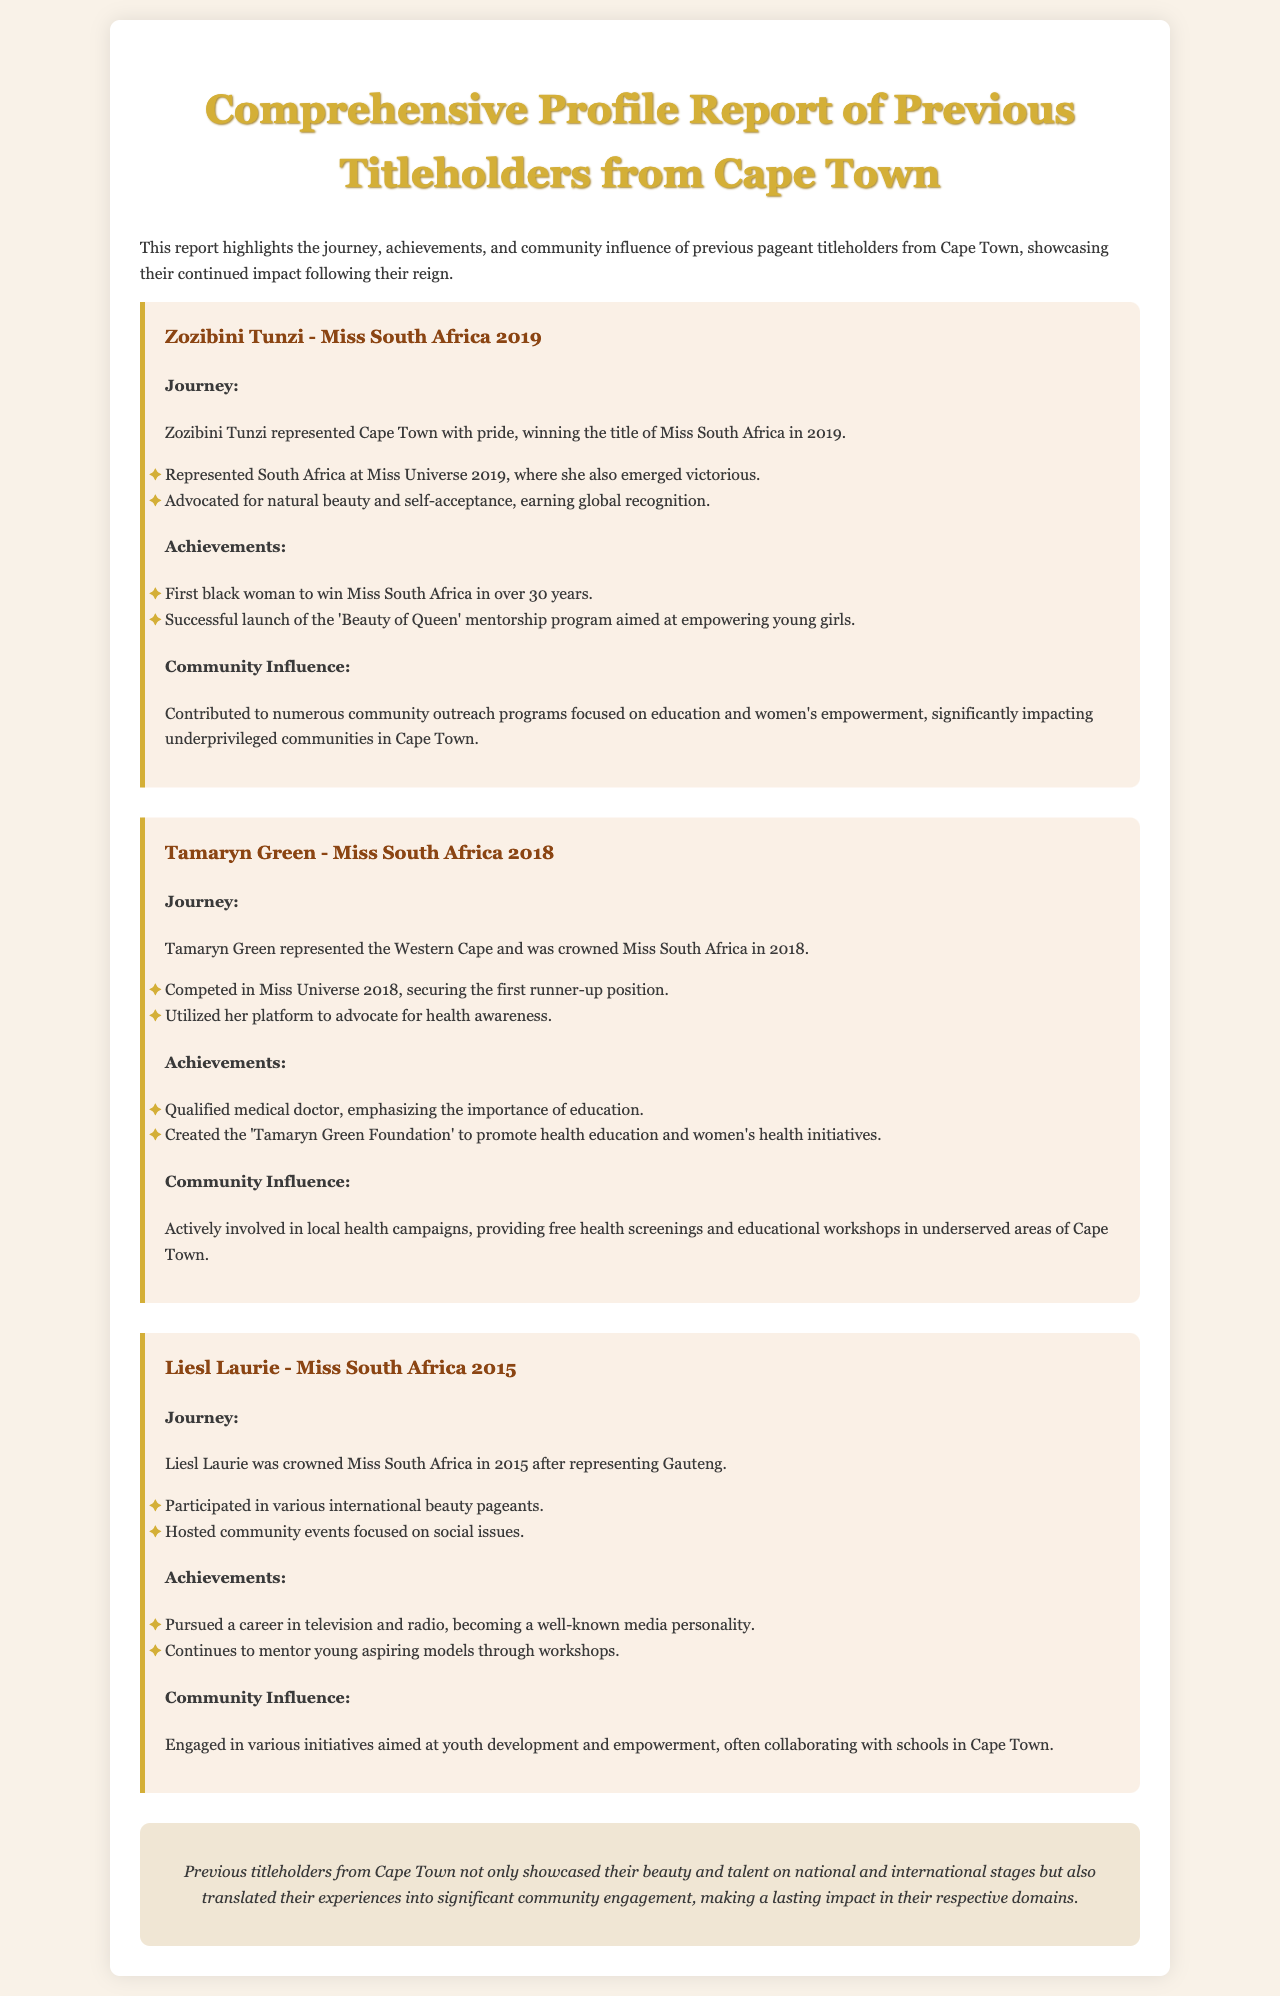What title did Zozibini Tunzi win? Zozibini Tunzi won the title of Miss South Africa in 2019.
Answer: Miss South Africa 2019 What foundation did Tamaryn Green create? Tamaryn Green created the 'Tamaryn Green Foundation' to promote health education.
Answer: Tamaryn Green Foundation How many years did it take for a black woman to win Miss South Africa before Zozibini Tunzi? Zozibini Tunzi was the first black woman to win Miss South Africa in over 30 years.
Answer: Over 30 years What was Liesl Laurie's profession after winning the title? Liesl Laurie pursued a career in television and radio, becoming a media personality.
Answer: Media personality What health initiative did Tamaryn Green advocate for? Tamaryn Green utilized her platform to advocate for health awareness.
Answer: Health awareness How did Zozibini Tunzi impact her community? Zozibini Tunzi contributed to numerous community outreach programs focused on education and women's empowerment.
Answer: Education and women's empowerment In what year did Liesl Laurie win her title? Liesl Laurie was crowned Miss South Africa in 2015.
Answer: 2015 What did Zozibini Tunzi's mentorship program aim to achieve? The 'Beauty of Queen' mentorship program aimed at empowering young girls.
Answer: Empowering young girls 